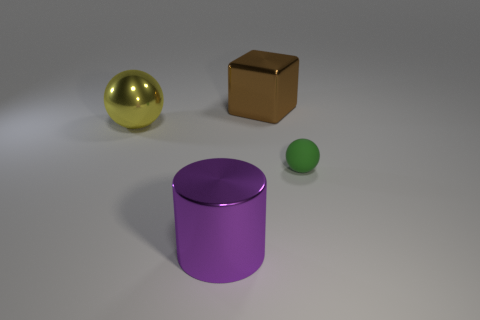Is there any other thing that is the same material as the small sphere?
Keep it short and to the point. No. How many cylinders are large purple metallic things or shiny things?
Make the answer very short. 1. Do the sphere that is left of the big brown cube and the shiny object right of the big metal cylinder have the same size?
Provide a short and direct response. Yes. What is the material of the sphere that is right of the ball to the left of the big metallic block?
Offer a terse response. Rubber. Are there fewer large yellow shiny balls to the right of the small object than shiny balls?
Provide a short and direct response. Yes. There is a large yellow object that is made of the same material as the large cylinder; what is its shape?
Keep it short and to the point. Sphere. How many other things are there of the same shape as the matte thing?
Provide a succinct answer. 1. How many red things are cylinders or large cubes?
Give a very brief answer. 0. Does the rubber thing have the same shape as the large yellow thing?
Your response must be concise. Yes. There is a big thing that is to the right of the purple shiny cylinder; are there any yellow balls that are in front of it?
Make the answer very short. Yes. 